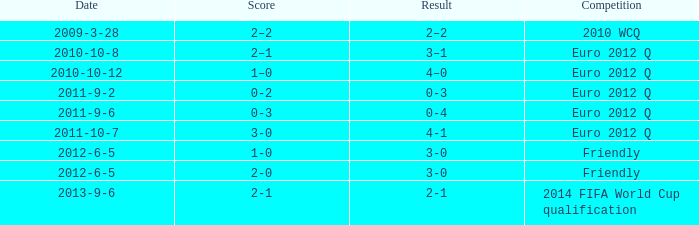When the score in a euro 2012 quarterfinal game is 3-0, how many goals have been scored in total? 1.0. 